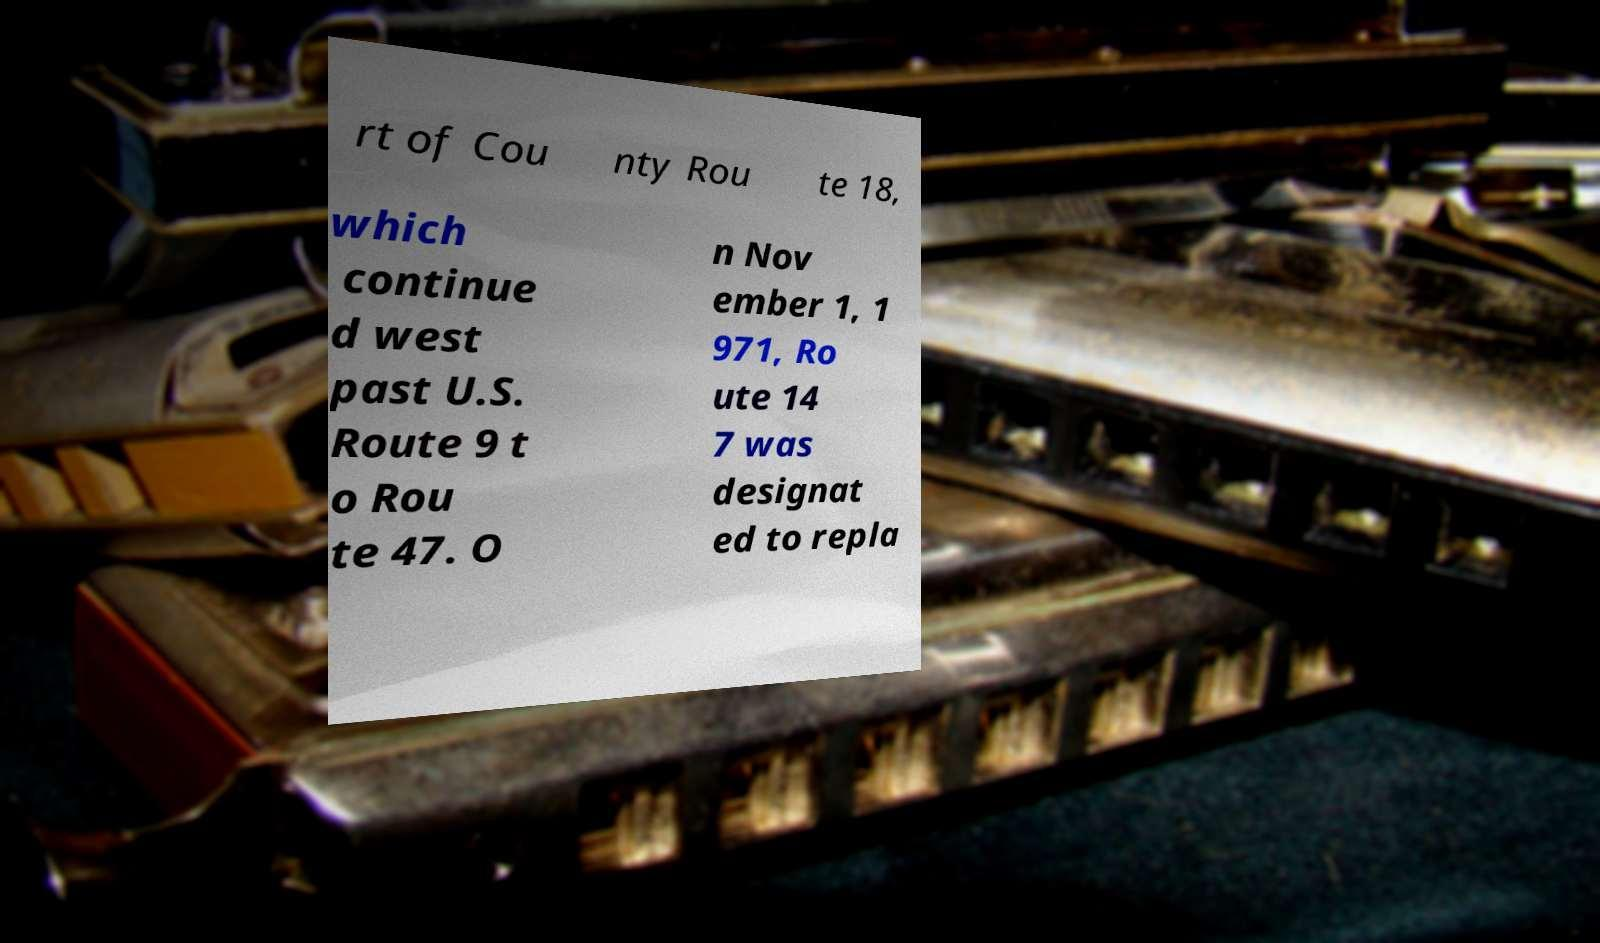I need the written content from this picture converted into text. Can you do that? rt of Cou nty Rou te 18, which continue d west past U.S. Route 9 t o Rou te 47. O n Nov ember 1, 1 971, Ro ute 14 7 was designat ed to repla 